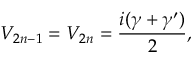Convert formula to latex. <formula><loc_0><loc_0><loc_500><loc_500>V _ { 2 n - 1 } = V _ { 2 n } = \frac { i ( \gamma + \gamma ^ { \prime } ) } { 2 } ,</formula> 